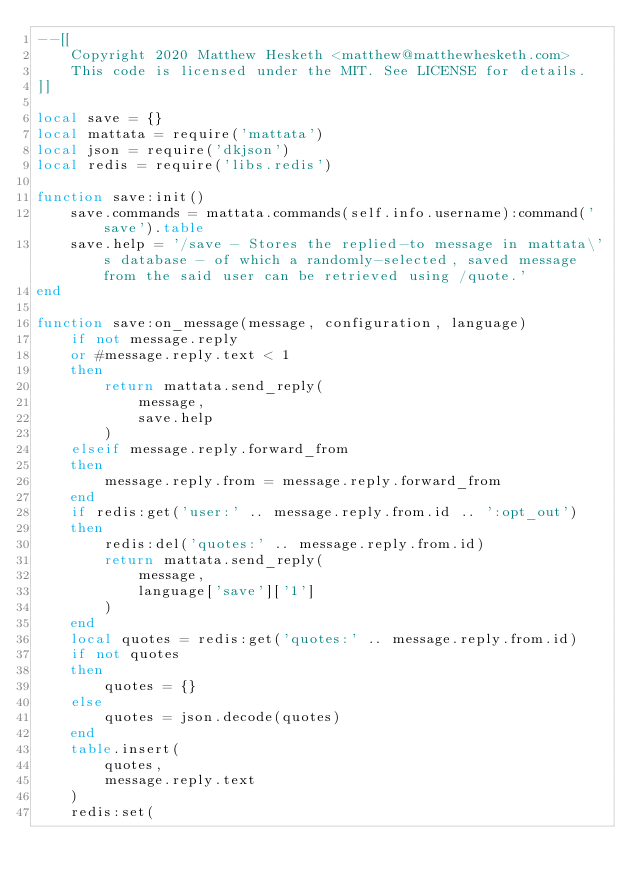<code> <loc_0><loc_0><loc_500><loc_500><_Lua_>--[[
    Copyright 2020 Matthew Hesketh <matthew@matthewhesketh.com>
    This code is licensed under the MIT. See LICENSE for details.
]]

local save = {}
local mattata = require('mattata')
local json = require('dkjson')
local redis = require('libs.redis')

function save:init()
    save.commands = mattata.commands(self.info.username):command('save').table
    save.help = '/save - Stores the replied-to message in mattata\'s database - of which a randomly-selected, saved message from the said user can be retrieved using /quote.'
end

function save:on_message(message, configuration, language)
    if not message.reply
    or #message.reply.text < 1
    then
        return mattata.send_reply(
            message,
            save.help
        )
    elseif message.reply.forward_from
    then
        message.reply.from = message.reply.forward_from
    end
    if redis:get('user:' .. message.reply.from.id .. ':opt_out')
    then
        redis:del('quotes:' .. message.reply.from.id)
        return mattata.send_reply(
            message,
            language['save']['1']
        )
    end
    local quotes = redis:get('quotes:' .. message.reply.from.id)
    if not quotes
    then
        quotes = {}
    else
        quotes = json.decode(quotes)
    end
    table.insert(
        quotes,
        message.reply.text
    )
    redis:set(</code> 